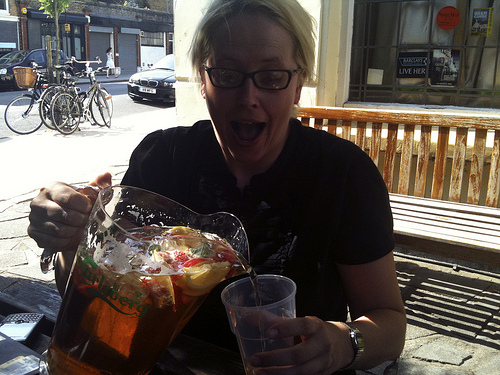<image>
Can you confirm if the bicycle is in front of the car? Yes. The bicycle is positioned in front of the car, appearing closer to the camera viewpoint. 